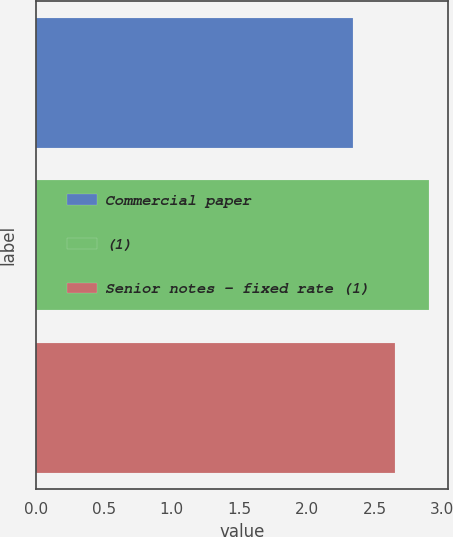Convert chart. <chart><loc_0><loc_0><loc_500><loc_500><bar_chart><fcel>Commercial paper<fcel>(1)<fcel>Senior notes - fixed rate (1)<nl><fcel>2.34<fcel>2.9<fcel>2.65<nl></chart> 